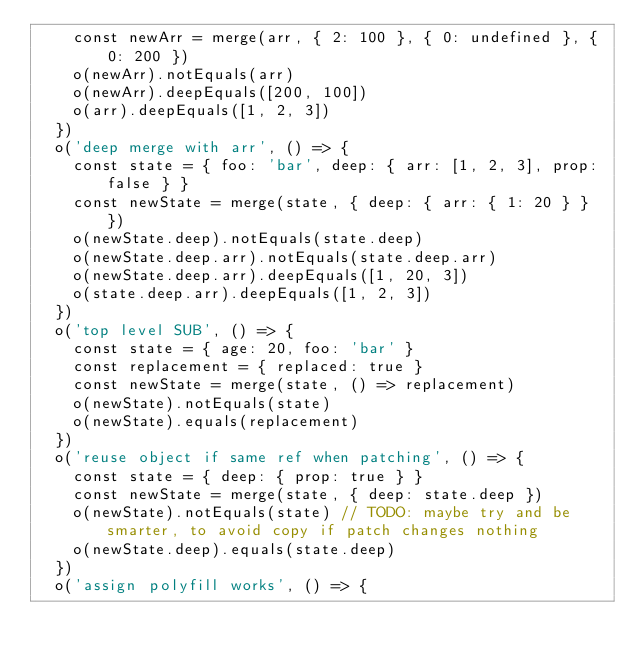<code> <loc_0><loc_0><loc_500><loc_500><_JavaScript_>    const newArr = merge(arr, { 2: 100 }, { 0: undefined }, { 0: 200 })
    o(newArr).notEquals(arr)
    o(newArr).deepEquals([200, 100])
    o(arr).deepEquals([1, 2, 3])
  })
  o('deep merge with arr', () => {
    const state = { foo: 'bar', deep: { arr: [1, 2, 3], prop: false } }
    const newState = merge(state, { deep: { arr: { 1: 20 } } })
    o(newState.deep).notEquals(state.deep)
    o(newState.deep.arr).notEquals(state.deep.arr)
    o(newState.deep.arr).deepEquals([1, 20, 3])
    o(state.deep.arr).deepEquals([1, 2, 3])
  })
  o('top level SUB', () => {
    const state = { age: 20, foo: 'bar' }
    const replacement = { replaced: true }
    const newState = merge(state, () => replacement)
    o(newState).notEquals(state)
    o(newState).equals(replacement)
  })
  o('reuse object if same ref when patching', () => {
    const state = { deep: { prop: true } }
    const newState = merge(state, { deep: state.deep })
    o(newState).notEquals(state) // TODO: maybe try and be smarter, to avoid copy if patch changes nothing
    o(newState.deep).equals(state.deep)
  })
  o('assign polyfill works', () => {</code> 